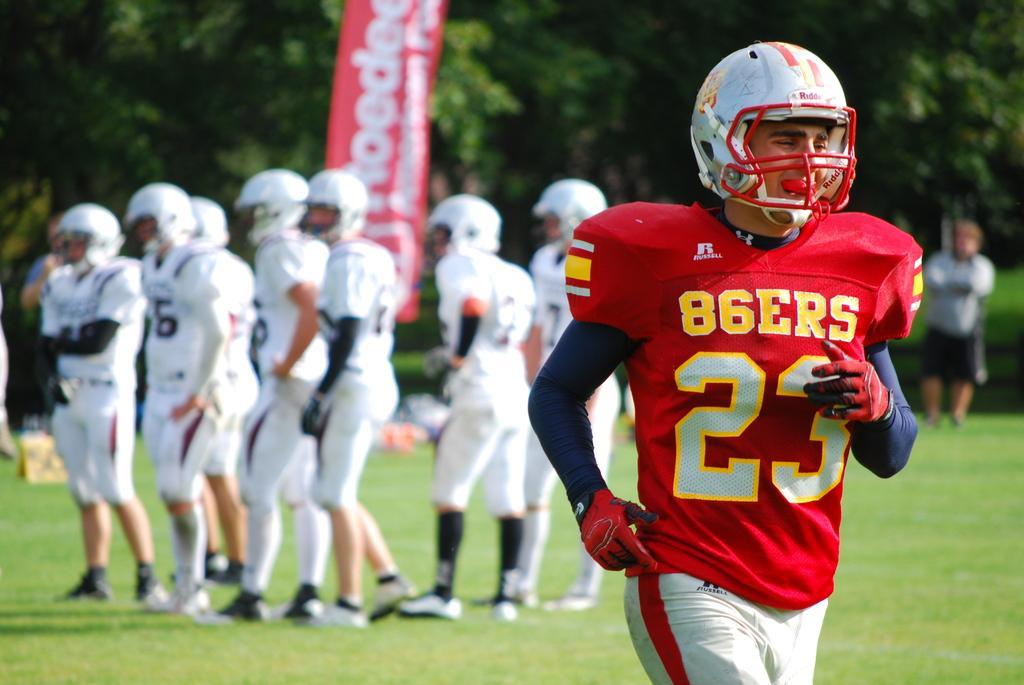In one or two sentences, can you explain what this image depicts? In this image I can see a person wearing red, black and white colored dress is standing. In the background I can see few persons wearing white colored dresses are standing, a banner and few trees which are green in color. 